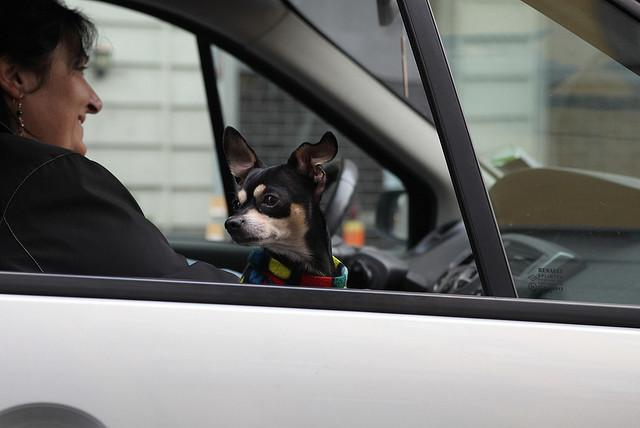What is this dog's owner doing? Please explain your reasoning. driving. The dog's owner drives. 